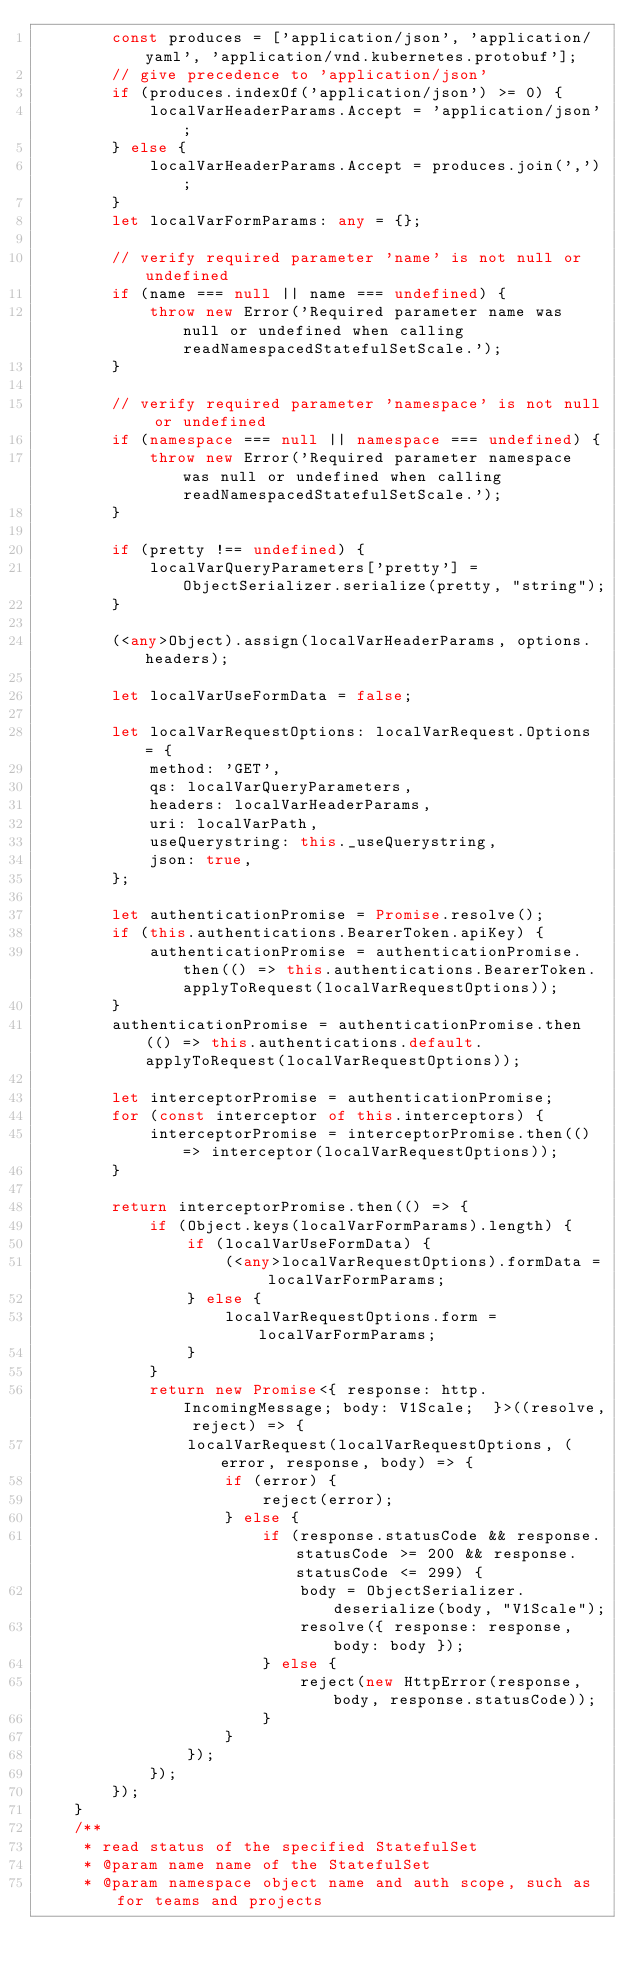<code> <loc_0><loc_0><loc_500><loc_500><_TypeScript_>        const produces = ['application/json', 'application/yaml', 'application/vnd.kubernetes.protobuf'];
        // give precedence to 'application/json'
        if (produces.indexOf('application/json') >= 0) {
            localVarHeaderParams.Accept = 'application/json';
        } else {
            localVarHeaderParams.Accept = produces.join(',');
        }
        let localVarFormParams: any = {};

        // verify required parameter 'name' is not null or undefined
        if (name === null || name === undefined) {
            throw new Error('Required parameter name was null or undefined when calling readNamespacedStatefulSetScale.');
        }

        // verify required parameter 'namespace' is not null or undefined
        if (namespace === null || namespace === undefined) {
            throw new Error('Required parameter namespace was null or undefined when calling readNamespacedStatefulSetScale.');
        }

        if (pretty !== undefined) {
            localVarQueryParameters['pretty'] = ObjectSerializer.serialize(pretty, "string");
        }

        (<any>Object).assign(localVarHeaderParams, options.headers);

        let localVarUseFormData = false;

        let localVarRequestOptions: localVarRequest.Options = {
            method: 'GET',
            qs: localVarQueryParameters,
            headers: localVarHeaderParams,
            uri: localVarPath,
            useQuerystring: this._useQuerystring,
            json: true,
        };

        let authenticationPromise = Promise.resolve();
        if (this.authentications.BearerToken.apiKey) {
            authenticationPromise = authenticationPromise.then(() => this.authentications.BearerToken.applyToRequest(localVarRequestOptions));
        }
        authenticationPromise = authenticationPromise.then(() => this.authentications.default.applyToRequest(localVarRequestOptions));

        let interceptorPromise = authenticationPromise;
        for (const interceptor of this.interceptors) {
            interceptorPromise = interceptorPromise.then(() => interceptor(localVarRequestOptions));
        }

        return interceptorPromise.then(() => {
            if (Object.keys(localVarFormParams).length) {
                if (localVarUseFormData) {
                    (<any>localVarRequestOptions).formData = localVarFormParams;
                } else {
                    localVarRequestOptions.form = localVarFormParams;
                }
            }
            return new Promise<{ response: http.IncomingMessage; body: V1Scale;  }>((resolve, reject) => {
                localVarRequest(localVarRequestOptions, (error, response, body) => {
                    if (error) {
                        reject(error);
                    } else {
                        if (response.statusCode && response.statusCode >= 200 && response.statusCode <= 299) {
                            body = ObjectSerializer.deserialize(body, "V1Scale");
                            resolve({ response: response, body: body });
                        } else {
                            reject(new HttpError(response, body, response.statusCode));
                        }
                    }
                });
            });
        });
    }
    /**
     * read status of the specified StatefulSet
     * @param name name of the StatefulSet
     * @param namespace object name and auth scope, such as for teams and projects</code> 